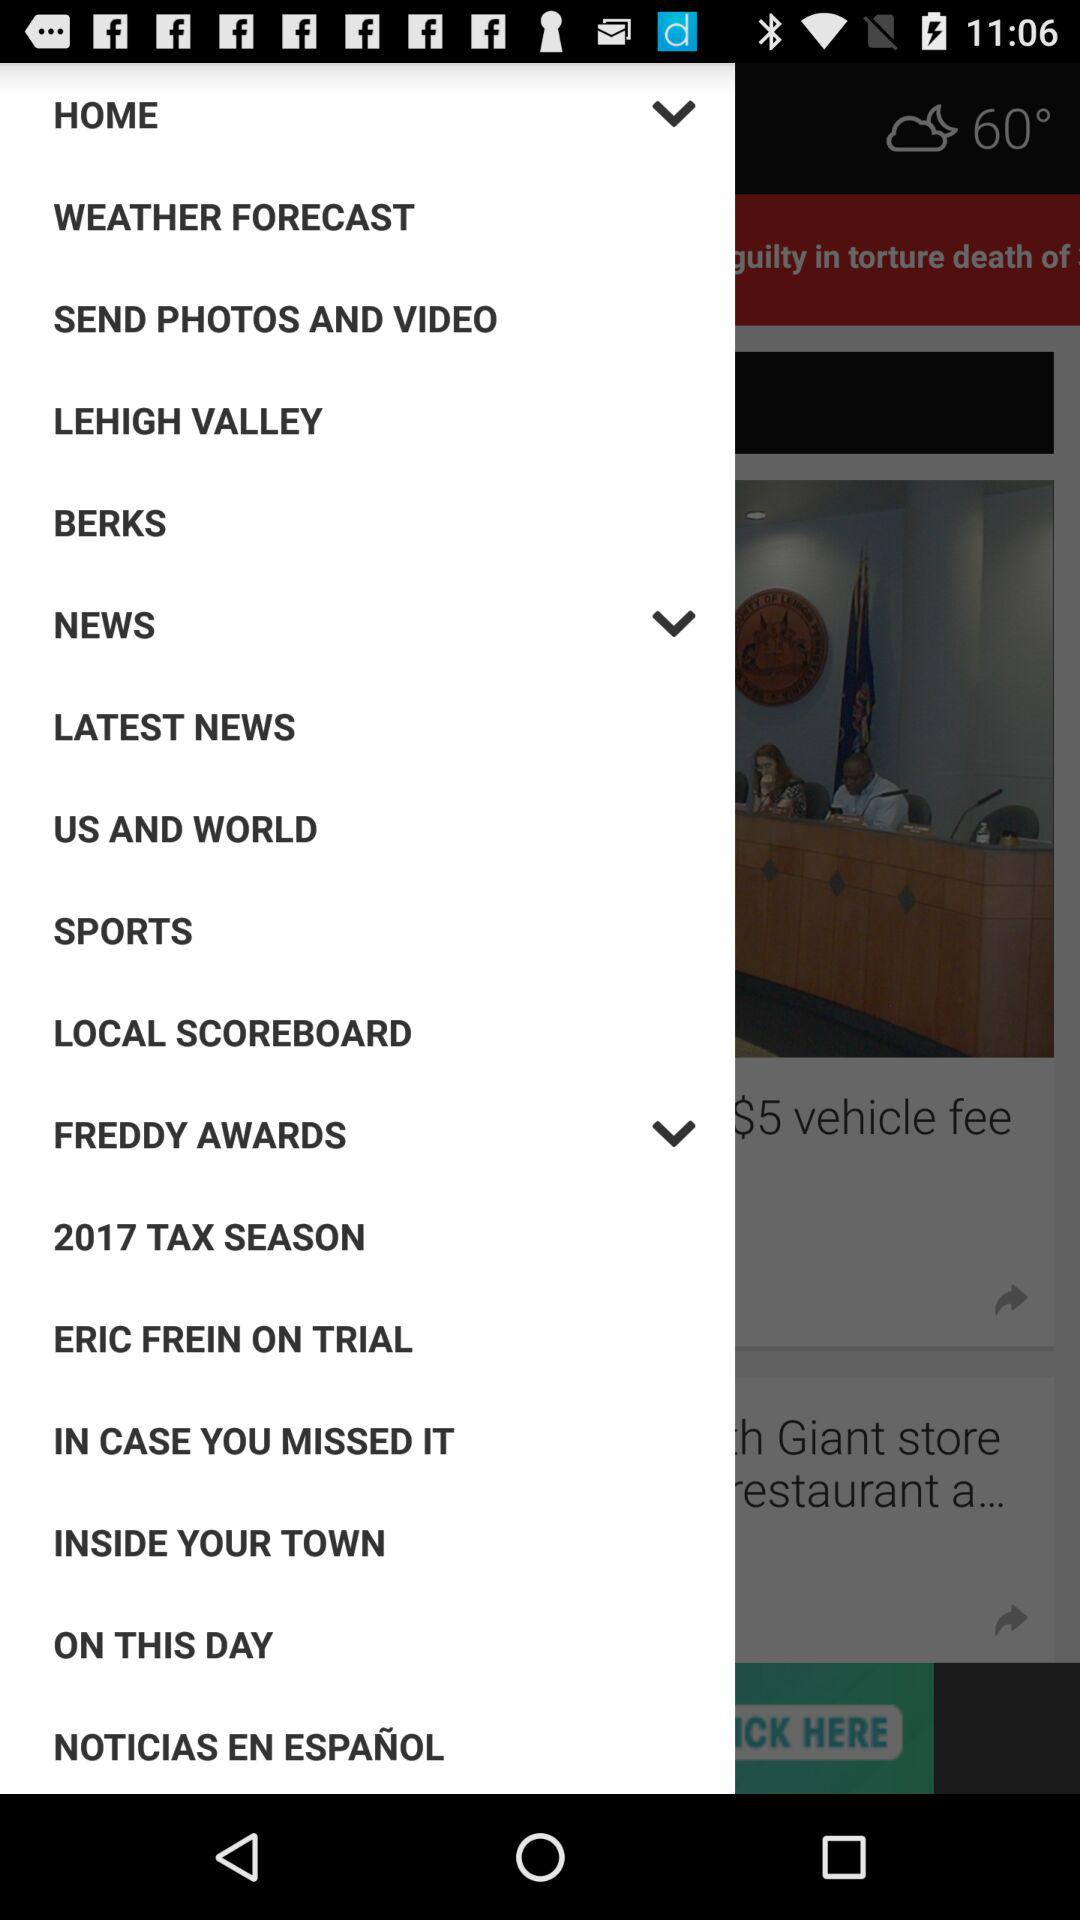What is the year for tax? The year is 2017. 